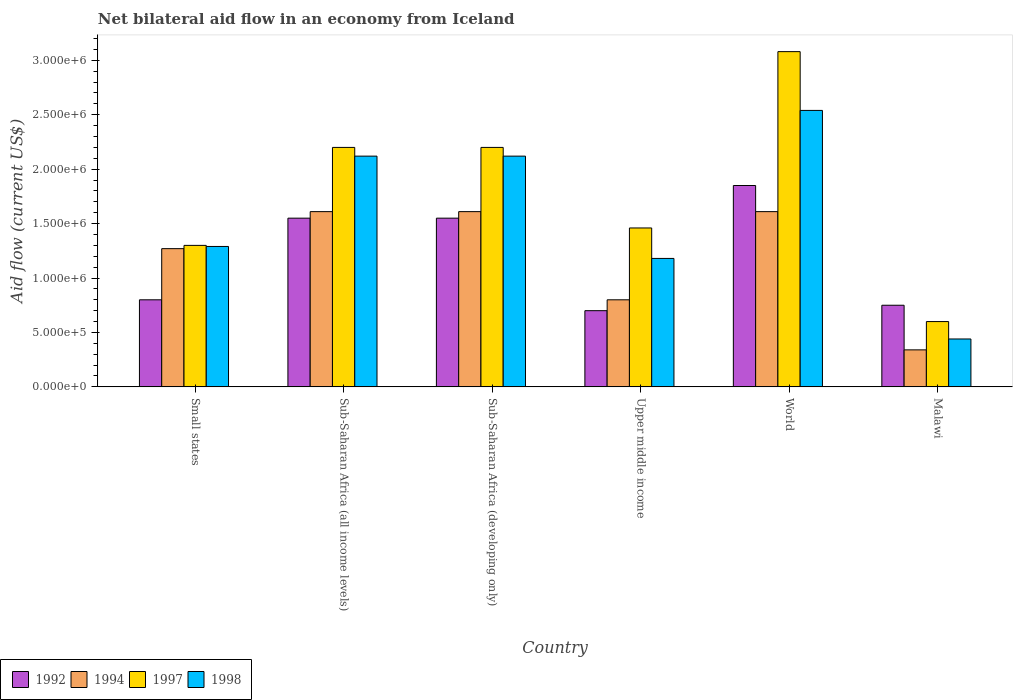Are the number of bars per tick equal to the number of legend labels?
Ensure brevity in your answer.  Yes. Are the number of bars on each tick of the X-axis equal?
Make the answer very short. Yes. What is the label of the 3rd group of bars from the left?
Your answer should be very brief. Sub-Saharan Africa (developing only). What is the net bilateral aid flow in 1994 in Sub-Saharan Africa (all income levels)?
Ensure brevity in your answer.  1.61e+06. Across all countries, what is the maximum net bilateral aid flow in 1998?
Provide a short and direct response. 2.54e+06. In which country was the net bilateral aid flow in 1994 maximum?
Your answer should be very brief. Sub-Saharan Africa (all income levels). In which country was the net bilateral aid flow in 1998 minimum?
Make the answer very short. Malawi. What is the total net bilateral aid flow in 1997 in the graph?
Provide a succinct answer. 1.08e+07. What is the difference between the net bilateral aid flow in 1994 in Sub-Saharan Africa (all income levels) and that in Upper middle income?
Provide a succinct answer. 8.10e+05. What is the difference between the net bilateral aid flow in 1998 in World and the net bilateral aid flow in 1997 in Small states?
Offer a very short reply. 1.24e+06. What is the average net bilateral aid flow in 1998 per country?
Provide a succinct answer. 1.62e+06. What is the ratio of the net bilateral aid flow in 1998 in Small states to that in World?
Make the answer very short. 0.51. Is the net bilateral aid flow in 1998 in Malawi less than that in Sub-Saharan Africa (all income levels)?
Offer a terse response. Yes. Is the difference between the net bilateral aid flow in 1998 in Small states and Sub-Saharan Africa (all income levels) greater than the difference between the net bilateral aid flow in 1992 in Small states and Sub-Saharan Africa (all income levels)?
Offer a terse response. No. What is the difference between the highest and the lowest net bilateral aid flow in 1994?
Provide a short and direct response. 1.27e+06. In how many countries, is the net bilateral aid flow in 1998 greater than the average net bilateral aid flow in 1998 taken over all countries?
Make the answer very short. 3. Is the sum of the net bilateral aid flow in 1992 in Malawi and Upper middle income greater than the maximum net bilateral aid flow in 1997 across all countries?
Your answer should be very brief. No. Is it the case that in every country, the sum of the net bilateral aid flow in 1997 and net bilateral aid flow in 1992 is greater than the sum of net bilateral aid flow in 1994 and net bilateral aid flow in 1998?
Your answer should be compact. No. What does the 1st bar from the left in Small states represents?
Give a very brief answer. 1992. What is the difference between two consecutive major ticks on the Y-axis?
Give a very brief answer. 5.00e+05. Are the values on the major ticks of Y-axis written in scientific E-notation?
Give a very brief answer. Yes. Does the graph contain grids?
Give a very brief answer. No. Where does the legend appear in the graph?
Your response must be concise. Bottom left. How are the legend labels stacked?
Your answer should be very brief. Horizontal. What is the title of the graph?
Give a very brief answer. Net bilateral aid flow in an economy from Iceland. Does "1999" appear as one of the legend labels in the graph?
Your answer should be compact. No. What is the Aid flow (current US$) in 1994 in Small states?
Your answer should be very brief. 1.27e+06. What is the Aid flow (current US$) in 1997 in Small states?
Provide a succinct answer. 1.30e+06. What is the Aid flow (current US$) in 1998 in Small states?
Offer a terse response. 1.29e+06. What is the Aid flow (current US$) of 1992 in Sub-Saharan Africa (all income levels)?
Offer a very short reply. 1.55e+06. What is the Aid flow (current US$) in 1994 in Sub-Saharan Africa (all income levels)?
Give a very brief answer. 1.61e+06. What is the Aid flow (current US$) of 1997 in Sub-Saharan Africa (all income levels)?
Your answer should be compact. 2.20e+06. What is the Aid flow (current US$) in 1998 in Sub-Saharan Africa (all income levels)?
Offer a terse response. 2.12e+06. What is the Aid flow (current US$) of 1992 in Sub-Saharan Africa (developing only)?
Provide a succinct answer. 1.55e+06. What is the Aid flow (current US$) of 1994 in Sub-Saharan Africa (developing only)?
Ensure brevity in your answer.  1.61e+06. What is the Aid flow (current US$) of 1997 in Sub-Saharan Africa (developing only)?
Provide a succinct answer. 2.20e+06. What is the Aid flow (current US$) of 1998 in Sub-Saharan Africa (developing only)?
Keep it short and to the point. 2.12e+06. What is the Aid flow (current US$) of 1994 in Upper middle income?
Offer a very short reply. 8.00e+05. What is the Aid flow (current US$) of 1997 in Upper middle income?
Provide a short and direct response. 1.46e+06. What is the Aid flow (current US$) in 1998 in Upper middle income?
Provide a short and direct response. 1.18e+06. What is the Aid flow (current US$) in 1992 in World?
Ensure brevity in your answer.  1.85e+06. What is the Aid flow (current US$) of 1994 in World?
Offer a very short reply. 1.61e+06. What is the Aid flow (current US$) of 1997 in World?
Your response must be concise. 3.08e+06. What is the Aid flow (current US$) of 1998 in World?
Your response must be concise. 2.54e+06. What is the Aid flow (current US$) in 1992 in Malawi?
Provide a short and direct response. 7.50e+05. What is the Aid flow (current US$) in 1998 in Malawi?
Your answer should be very brief. 4.40e+05. Across all countries, what is the maximum Aid flow (current US$) of 1992?
Offer a very short reply. 1.85e+06. Across all countries, what is the maximum Aid flow (current US$) of 1994?
Your answer should be compact. 1.61e+06. Across all countries, what is the maximum Aid flow (current US$) in 1997?
Keep it short and to the point. 3.08e+06. Across all countries, what is the maximum Aid flow (current US$) in 1998?
Offer a very short reply. 2.54e+06. Across all countries, what is the minimum Aid flow (current US$) of 1992?
Give a very brief answer. 7.00e+05. Across all countries, what is the minimum Aid flow (current US$) in 1997?
Offer a terse response. 6.00e+05. Across all countries, what is the minimum Aid flow (current US$) of 1998?
Keep it short and to the point. 4.40e+05. What is the total Aid flow (current US$) of 1992 in the graph?
Offer a terse response. 7.20e+06. What is the total Aid flow (current US$) of 1994 in the graph?
Keep it short and to the point. 7.24e+06. What is the total Aid flow (current US$) in 1997 in the graph?
Offer a terse response. 1.08e+07. What is the total Aid flow (current US$) of 1998 in the graph?
Your answer should be very brief. 9.69e+06. What is the difference between the Aid flow (current US$) in 1992 in Small states and that in Sub-Saharan Africa (all income levels)?
Keep it short and to the point. -7.50e+05. What is the difference between the Aid flow (current US$) in 1997 in Small states and that in Sub-Saharan Africa (all income levels)?
Keep it short and to the point. -9.00e+05. What is the difference between the Aid flow (current US$) in 1998 in Small states and that in Sub-Saharan Africa (all income levels)?
Provide a succinct answer. -8.30e+05. What is the difference between the Aid flow (current US$) in 1992 in Small states and that in Sub-Saharan Africa (developing only)?
Your answer should be very brief. -7.50e+05. What is the difference between the Aid flow (current US$) in 1994 in Small states and that in Sub-Saharan Africa (developing only)?
Offer a terse response. -3.40e+05. What is the difference between the Aid flow (current US$) of 1997 in Small states and that in Sub-Saharan Africa (developing only)?
Your response must be concise. -9.00e+05. What is the difference between the Aid flow (current US$) in 1998 in Small states and that in Sub-Saharan Africa (developing only)?
Offer a terse response. -8.30e+05. What is the difference between the Aid flow (current US$) of 1992 in Small states and that in Upper middle income?
Provide a short and direct response. 1.00e+05. What is the difference between the Aid flow (current US$) of 1994 in Small states and that in Upper middle income?
Your response must be concise. 4.70e+05. What is the difference between the Aid flow (current US$) of 1998 in Small states and that in Upper middle income?
Keep it short and to the point. 1.10e+05. What is the difference between the Aid flow (current US$) of 1992 in Small states and that in World?
Make the answer very short. -1.05e+06. What is the difference between the Aid flow (current US$) in 1994 in Small states and that in World?
Your answer should be compact. -3.40e+05. What is the difference between the Aid flow (current US$) in 1997 in Small states and that in World?
Provide a succinct answer. -1.78e+06. What is the difference between the Aid flow (current US$) of 1998 in Small states and that in World?
Ensure brevity in your answer.  -1.25e+06. What is the difference between the Aid flow (current US$) in 1992 in Small states and that in Malawi?
Provide a short and direct response. 5.00e+04. What is the difference between the Aid flow (current US$) in 1994 in Small states and that in Malawi?
Ensure brevity in your answer.  9.30e+05. What is the difference between the Aid flow (current US$) in 1997 in Small states and that in Malawi?
Keep it short and to the point. 7.00e+05. What is the difference between the Aid flow (current US$) in 1998 in Small states and that in Malawi?
Offer a terse response. 8.50e+05. What is the difference between the Aid flow (current US$) in 1994 in Sub-Saharan Africa (all income levels) and that in Sub-Saharan Africa (developing only)?
Make the answer very short. 0. What is the difference between the Aid flow (current US$) in 1997 in Sub-Saharan Africa (all income levels) and that in Sub-Saharan Africa (developing only)?
Your answer should be compact. 0. What is the difference between the Aid flow (current US$) of 1998 in Sub-Saharan Africa (all income levels) and that in Sub-Saharan Africa (developing only)?
Offer a terse response. 0. What is the difference between the Aid flow (current US$) in 1992 in Sub-Saharan Africa (all income levels) and that in Upper middle income?
Provide a succinct answer. 8.50e+05. What is the difference between the Aid flow (current US$) in 1994 in Sub-Saharan Africa (all income levels) and that in Upper middle income?
Your response must be concise. 8.10e+05. What is the difference between the Aid flow (current US$) of 1997 in Sub-Saharan Africa (all income levels) and that in Upper middle income?
Your response must be concise. 7.40e+05. What is the difference between the Aid flow (current US$) in 1998 in Sub-Saharan Africa (all income levels) and that in Upper middle income?
Provide a succinct answer. 9.40e+05. What is the difference between the Aid flow (current US$) in 1992 in Sub-Saharan Africa (all income levels) and that in World?
Your response must be concise. -3.00e+05. What is the difference between the Aid flow (current US$) of 1997 in Sub-Saharan Africa (all income levels) and that in World?
Offer a terse response. -8.80e+05. What is the difference between the Aid flow (current US$) of 1998 in Sub-Saharan Africa (all income levels) and that in World?
Keep it short and to the point. -4.20e+05. What is the difference between the Aid flow (current US$) in 1994 in Sub-Saharan Africa (all income levels) and that in Malawi?
Offer a terse response. 1.27e+06. What is the difference between the Aid flow (current US$) of 1997 in Sub-Saharan Africa (all income levels) and that in Malawi?
Offer a very short reply. 1.60e+06. What is the difference between the Aid flow (current US$) in 1998 in Sub-Saharan Africa (all income levels) and that in Malawi?
Offer a very short reply. 1.68e+06. What is the difference between the Aid flow (current US$) in 1992 in Sub-Saharan Africa (developing only) and that in Upper middle income?
Ensure brevity in your answer.  8.50e+05. What is the difference between the Aid flow (current US$) of 1994 in Sub-Saharan Africa (developing only) and that in Upper middle income?
Ensure brevity in your answer.  8.10e+05. What is the difference between the Aid flow (current US$) of 1997 in Sub-Saharan Africa (developing only) and that in Upper middle income?
Offer a very short reply. 7.40e+05. What is the difference between the Aid flow (current US$) of 1998 in Sub-Saharan Africa (developing only) and that in Upper middle income?
Give a very brief answer. 9.40e+05. What is the difference between the Aid flow (current US$) in 1992 in Sub-Saharan Africa (developing only) and that in World?
Give a very brief answer. -3.00e+05. What is the difference between the Aid flow (current US$) of 1997 in Sub-Saharan Africa (developing only) and that in World?
Your answer should be very brief. -8.80e+05. What is the difference between the Aid flow (current US$) of 1998 in Sub-Saharan Africa (developing only) and that in World?
Make the answer very short. -4.20e+05. What is the difference between the Aid flow (current US$) in 1992 in Sub-Saharan Africa (developing only) and that in Malawi?
Your answer should be compact. 8.00e+05. What is the difference between the Aid flow (current US$) of 1994 in Sub-Saharan Africa (developing only) and that in Malawi?
Your response must be concise. 1.27e+06. What is the difference between the Aid flow (current US$) of 1997 in Sub-Saharan Africa (developing only) and that in Malawi?
Keep it short and to the point. 1.60e+06. What is the difference between the Aid flow (current US$) of 1998 in Sub-Saharan Africa (developing only) and that in Malawi?
Your answer should be compact. 1.68e+06. What is the difference between the Aid flow (current US$) in 1992 in Upper middle income and that in World?
Your response must be concise. -1.15e+06. What is the difference between the Aid flow (current US$) of 1994 in Upper middle income and that in World?
Your response must be concise. -8.10e+05. What is the difference between the Aid flow (current US$) in 1997 in Upper middle income and that in World?
Give a very brief answer. -1.62e+06. What is the difference between the Aid flow (current US$) in 1998 in Upper middle income and that in World?
Provide a succinct answer. -1.36e+06. What is the difference between the Aid flow (current US$) of 1997 in Upper middle income and that in Malawi?
Provide a short and direct response. 8.60e+05. What is the difference between the Aid flow (current US$) of 1998 in Upper middle income and that in Malawi?
Offer a very short reply. 7.40e+05. What is the difference between the Aid flow (current US$) in 1992 in World and that in Malawi?
Your answer should be very brief. 1.10e+06. What is the difference between the Aid flow (current US$) in 1994 in World and that in Malawi?
Ensure brevity in your answer.  1.27e+06. What is the difference between the Aid flow (current US$) of 1997 in World and that in Malawi?
Offer a very short reply. 2.48e+06. What is the difference between the Aid flow (current US$) in 1998 in World and that in Malawi?
Provide a succinct answer. 2.10e+06. What is the difference between the Aid flow (current US$) of 1992 in Small states and the Aid flow (current US$) of 1994 in Sub-Saharan Africa (all income levels)?
Give a very brief answer. -8.10e+05. What is the difference between the Aid flow (current US$) of 1992 in Small states and the Aid flow (current US$) of 1997 in Sub-Saharan Africa (all income levels)?
Your answer should be compact. -1.40e+06. What is the difference between the Aid flow (current US$) in 1992 in Small states and the Aid flow (current US$) in 1998 in Sub-Saharan Africa (all income levels)?
Provide a short and direct response. -1.32e+06. What is the difference between the Aid flow (current US$) in 1994 in Small states and the Aid flow (current US$) in 1997 in Sub-Saharan Africa (all income levels)?
Keep it short and to the point. -9.30e+05. What is the difference between the Aid flow (current US$) in 1994 in Small states and the Aid flow (current US$) in 1998 in Sub-Saharan Africa (all income levels)?
Give a very brief answer. -8.50e+05. What is the difference between the Aid flow (current US$) of 1997 in Small states and the Aid flow (current US$) of 1998 in Sub-Saharan Africa (all income levels)?
Give a very brief answer. -8.20e+05. What is the difference between the Aid flow (current US$) of 1992 in Small states and the Aid flow (current US$) of 1994 in Sub-Saharan Africa (developing only)?
Ensure brevity in your answer.  -8.10e+05. What is the difference between the Aid flow (current US$) in 1992 in Small states and the Aid flow (current US$) in 1997 in Sub-Saharan Africa (developing only)?
Make the answer very short. -1.40e+06. What is the difference between the Aid flow (current US$) of 1992 in Small states and the Aid flow (current US$) of 1998 in Sub-Saharan Africa (developing only)?
Ensure brevity in your answer.  -1.32e+06. What is the difference between the Aid flow (current US$) of 1994 in Small states and the Aid flow (current US$) of 1997 in Sub-Saharan Africa (developing only)?
Your answer should be compact. -9.30e+05. What is the difference between the Aid flow (current US$) of 1994 in Small states and the Aid flow (current US$) of 1998 in Sub-Saharan Africa (developing only)?
Make the answer very short. -8.50e+05. What is the difference between the Aid flow (current US$) in 1997 in Small states and the Aid flow (current US$) in 1998 in Sub-Saharan Africa (developing only)?
Give a very brief answer. -8.20e+05. What is the difference between the Aid flow (current US$) of 1992 in Small states and the Aid flow (current US$) of 1994 in Upper middle income?
Your response must be concise. 0. What is the difference between the Aid flow (current US$) in 1992 in Small states and the Aid flow (current US$) in 1997 in Upper middle income?
Offer a terse response. -6.60e+05. What is the difference between the Aid flow (current US$) in 1992 in Small states and the Aid flow (current US$) in 1998 in Upper middle income?
Make the answer very short. -3.80e+05. What is the difference between the Aid flow (current US$) of 1994 in Small states and the Aid flow (current US$) of 1997 in Upper middle income?
Give a very brief answer. -1.90e+05. What is the difference between the Aid flow (current US$) of 1992 in Small states and the Aid flow (current US$) of 1994 in World?
Your response must be concise. -8.10e+05. What is the difference between the Aid flow (current US$) of 1992 in Small states and the Aid flow (current US$) of 1997 in World?
Your answer should be compact. -2.28e+06. What is the difference between the Aid flow (current US$) in 1992 in Small states and the Aid flow (current US$) in 1998 in World?
Provide a succinct answer. -1.74e+06. What is the difference between the Aid flow (current US$) in 1994 in Small states and the Aid flow (current US$) in 1997 in World?
Your response must be concise. -1.81e+06. What is the difference between the Aid flow (current US$) of 1994 in Small states and the Aid flow (current US$) of 1998 in World?
Your response must be concise. -1.27e+06. What is the difference between the Aid flow (current US$) in 1997 in Small states and the Aid flow (current US$) in 1998 in World?
Provide a succinct answer. -1.24e+06. What is the difference between the Aid flow (current US$) in 1992 in Small states and the Aid flow (current US$) in 1994 in Malawi?
Your answer should be compact. 4.60e+05. What is the difference between the Aid flow (current US$) in 1992 in Small states and the Aid flow (current US$) in 1997 in Malawi?
Your answer should be very brief. 2.00e+05. What is the difference between the Aid flow (current US$) of 1994 in Small states and the Aid flow (current US$) of 1997 in Malawi?
Offer a terse response. 6.70e+05. What is the difference between the Aid flow (current US$) in 1994 in Small states and the Aid flow (current US$) in 1998 in Malawi?
Make the answer very short. 8.30e+05. What is the difference between the Aid flow (current US$) in 1997 in Small states and the Aid flow (current US$) in 1998 in Malawi?
Offer a very short reply. 8.60e+05. What is the difference between the Aid flow (current US$) in 1992 in Sub-Saharan Africa (all income levels) and the Aid flow (current US$) in 1994 in Sub-Saharan Africa (developing only)?
Ensure brevity in your answer.  -6.00e+04. What is the difference between the Aid flow (current US$) of 1992 in Sub-Saharan Africa (all income levels) and the Aid flow (current US$) of 1997 in Sub-Saharan Africa (developing only)?
Keep it short and to the point. -6.50e+05. What is the difference between the Aid flow (current US$) of 1992 in Sub-Saharan Africa (all income levels) and the Aid flow (current US$) of 1998 in Sub-Saharan Africa (developing only)?
Offer a terse response. -5.70e+05. What is the difference between the Aid flow (current US$) in 1994 in Sub-Saharan Africa (all income levels) and the Aid flow (current US$) in 1997 in Sub-Saharan Africa (developing only)?
Make the answer very short. -5.90e+05. What is the difference between the Aid flow (current US$) in 1994 in Sub-Saharan Africa (all income levels) and the Aid flow (current US$) in 1998 in Sub-Saharan Africa (developing only)?
Provide a succinct answer. -5.10e+05. What is the difference between the Aid flow (current US$) in 1992 in Sub-Saharan Africa (all income levels) and the Aid flow (current US$) in 1994 in Upper middle income?
Offer a terse response. 7.50e+05. What is the difference between the Aid flow (current US$) in 1994 in Sub-Saharan Africa (all income levels) and the Aid flow (current US$) in 1998 in Upper middle income?
Your answer should be compact. 4.30e+05. What is the difference between the Aid flow (current US$) in 1997 in Sub-Saharan Africa (all income levels) and the Aid flow (current US$) in 1998 in Upper middle income?
Ensure brevity in your answer.  1.02e+06. What is the difference between the Aid flow (current US$) in 1992 in Sub-Saharan Africa (all income levels) and the Aid flow (current US$) in 1994 in World?
Provide a succinct answer. -6.00e+04. What is the difference between the Aid flow (current US$) in 1992 in Sub-Saharan Africa (all income levels) and the Aid flow (current US$) in 1997 in World?
Make the answer very short. -1.53e+06. What is the difference between the Aid flow (current US$) in 1992 in Sub-Saharan Africa (all income levels) and the Aid flow (current US$) in 1998 in World?
Provide a short and direct response. -9.90e+05. What is the difference between the Aid flow (current US$) of 1994 in Sub-Saharan Africa (all income levels) and the Aid flow (current US$) of 1997 in World?
Make the answer very short. -1.47e+06. What is the difference between the Aid flow (current US$) of 1994 in Sub-Saharan Africa (all income levels) and the Aid flow (current US$) of 1998 in World?
Your response must be concise. -9.30e+05. What is the difference between the Aid flow (current US$) of 1997 in Sub-Saharan Africa (all income levels) and the Aid flow (current US$) of 1998 in World?
Your response must be concise. -3.40e+05. What is the difference between the Aid flow (current US$) in 1992 in Sub-Saharan Africa (all income levels) and the Aid flow (current US$) in 1994 in Malawi?
Your answer should be very brief. 1.21e+06. What is the difference between the Aid flow (current US$) in 1992 in Sub-Saharan Africa (all income levels) and the Aid flow (current US$) in 1997 in Malawi?
Offer a very short reply. 9.50e+05. What is the difference between the Aid flow (current US$) in 1992 in Sub-Saharan Africa (all income levels) and the Aid flow (current US$) in 1998 in Malawi?
Offer a very short reply. 1.11e+06. What is the difference between the Aid flow (current US$) in 1994 in Sub-Saharan Africa (all income levels) and the Aid flow (current US$) in 1997 in Malawi?
Keep it short and to the point. 1.01e+06. What is the difference between the Aid flow (current US$) in 1994 in Sub-Saharan Africa (all income levels) and the Aid flow (current US$) in 1998 in Malawi?
Ensure brevity in your answer.  1.17e+06. What is the difference between the Aid flow (current US$) of 1997 in Sub-Saharan Africa (all income levels) and the Aid flow (current US$) of 1998 in Malawi?
Give a very brief answer. 1.76e+06. What is the difference between the Aid flow (current US$) of 1992 in Sub-Saharan Africa (developing only) and the Aid flow (current US$) of 1994 in Upper middle income?
Offer a terse response. 7.50e+05. What is the difference between the Aid flow (current US$) of 1994 in Sub-Saharan Africa (developing only) and the Aid flow (current US$) of 1997 in Upper middle income?
Give a very brief answer. 1.50e+05. What is the difference between the Aid flow (current US$) of 1997 in Sub-Saharan Africa (developing only) and the Aid flow (current US$) of 1998 in Upper middle income?
Your answer should be compact. 1.02e+06. What is the difference between the Aid flow (current US$) in 1992 in Sub-Saharan Africa (developing only) and the Aid flow (current US$) in 1997 in World?
Make the answer very short. -1.53e+06. What is the difference between the Aid flow (current US$) of 1992 in Sub-Saharan Africa (developing only) and the Aid flow (current US$) of 1998 in World?
Make the answer very short. -9.90e+05. What is the difference between the Aid flow (current US$) in 1994 in Sub-Saharan Africa (developing only) and the Aid flow (current US$) in 1997 in World?
Make the answer very short. -1.47e+06. What is the difference between the Aid flow (current US$) of 1994 in Sub-Saharan Africa (developing only) and the Aid flow (current US$) of 1998 in World?
Offer a very short reply. -9.30e+05. What is the difference between the Aid flow (current US$) in 1992 in Sub-Saharan Africa (developing only) and the Aid flow (current US$) in 1994 in Malawi?
Provide a short and direct response. 1.21e+06. What is the difference between the Aid flow (current US$) in 1992 in Sub-Saharan Africa (developing only) and the Aid flow (current US$) in 1997 in Malawi?
Provide a succinct answer. 9.50e+05. What is the difference between the Aid flow (current US$) in 1992 in Sub-Saharan Africa (developing only) and the Aid flow (current US$) in 1998 in Malawi?
Offer a very short reply. 1.11e+06. What is the difference between the Aid flow (current US$) in 1994 in Sub-Saharan Africa (developing only) and the Aid flow (current US$) in 1997 in Malawi?
Keep it short and to the point. 1.01e+06. What is the difference between the Aid flow (current US$) of 1994 in Sub-Saharan Africa (developing only) and the Aid flow (current US$) of 1998 in Malawi?
Offer a terse response. 1.17e+06. What is the difference between the Aid flow (current US$) in 1997 in Sub-Saharan Africa (developing only) and the Aid flow (current US$) in 1998 in Malawi?
Offer a very short reply. 1.76e+06. What is the difference between the Aid flow (current US$) in 1992 in Upper middle income and the Aid flow (current US$) in 1994 in World?
Keep it short and to the point. -9.10e+05. What is the difference between the Aid flow (current US$) of 1992 in Upper middle income and the Aid flow (current US$) of 1997 in World?
Your answer should be very brief. -2.38e+06. What is the difference between the Aid flow (current US$) of 1992 in Upper middle income and the Aid flow (current US$) of 1998 in World?
Your answer should be very brief. -1.84e+06. What is the difference between the Aid flow (current US$) in 1994 in Upper middle income and the Aid flow (current US$) in 1997 in World?
Make the answer very short. -2.28e+06. What is the difference between the Aid flow (current US$) in 1994 in Upper middle income and the Aid flow (current US$) in 1998 in World?
Make the answer very short. -1.74e+06. What is the difference between the Aid flow (current US$) of 1997 in Upper middle income and the Aid flow (current US$) of 1998 in World?
Ensure brevity in your answer.  -1.08e+06. What is the difference between the Aid flow (current US$) of 1992 in Upper middle income and the Aid flow (current US$) of 1997 in Malawi?
Make the answer very short. 1.00e+05. What is the difference between the Aid flow (current US$) in 1994 in Upper middle income and the Aid flow (current US$) in 1998 in Malawi?
Make the answer very short. 3.60e+05. What is the difference between the Aid flow (current US$) in 1997 in Upper middle income and the Aid flow (current US$) in 1998 in Malawi?
Your response must be concise. 1.02e+06. What is the difference between the Aid flow (current US$) of 1992 in World and the Aid flow (current US$) of 1994 in Malawi?
Offer a very short reply. 1.51e+06. What is the difference between the Aid flow (current US$) in 1992 in World and the Aid flow (current US$) in 1997 in Malawi?
Your answer should be compact. 1.25e+06. What is the difference between the Aid flow (current US$) of 1992 in World and the Aid flow (current US$) of 1998 in Malawi?
Offer a very short reply. 1.41e+06. What is the difference between the Aid flow (current US$) of 1994 in World and the Aid flow (current US$) of 1997 in Malawi?
Your response must be concise. 1.01e+06. What is the difference between the Aid flow (current US$) of 1994 in World and the Aid flow (current US$) of 1998 in Malawi?
Give a very brief answer. 1.17e+06. What is the difference between the Aid flow (current US$) in 1997 in World and the Aid flow (current US$) in 1998 in Malawi?
Offer a terse response. 2.64e+06. What is the average Aid flow (current US$) in 1992 per country?
Provide a succinct answer. 1.20e+06. What is the average Aid flow (current US$) of 1994 per country?
Provide a short and direct response. 1.21e+06. What is the average Aid flow (current US$) in 1997 per country?
Provide a short and direct response. 1.81e+06. What is the average Aid flow (current US$) of 1998 per country?
Your answer should be very brief. 1.62e+06. What is the difference between the Aid flow (current US$) in 1992 and Aid flow (current US$) in 1994 in Small states?
Your response must be concise. -4.70e+05. What is the difference between the Aid flow (current US$) in 1992 and Aid flow (current US$) in 1997 in Small states?
Your response must be concise. -5.00e+05. What is the difference between the Aid flow (current US$) of 1992 and Aid flow (current US$) of 1998 in Small states?
Your response must be concise. -4.90e+05. What is the difference between the Aid flow (current US$) in 1994 and Aid flow (current US$) in 1997 in Small states?
Ensure brevity in your answer.  -3.00e+04. What is the difference between the Aid flow (current US$) in 1992 and Aid flow (current US$) in 1997 in Sub-Saharan Africa (all income levels)?
Keep it short and to the point. -6.50e+05. What is the difference between the Aid flow (current US$) of 1992 and Aid flow (current US$) of 1998 in Sub-Saharan Africa (all income levels)?
Make the answer very short. -5.70e+05. What is the difference between the Aid flow (current US$) of 1994 and Aid flow (current US$) of 1997 in Sub-Saharan Africa (all income levels)?
Offer a very short reply. -5.90e+05. What is the difference between the Aid flow (current US$) of 1994 and Aid flow (current US$) of 1998 in Sub-Saharan Africa (all income levels)?
Offer a very short reply. -5.10e+05. What is the difference between the Aid flow (current US$) in 1997 and Aid flow (current US$) in 1998 in Sub-Saharan Africa (all income levels)?
Ensure brevity in your answer.  8.00e+04. What is the difference between the Aid flow (current US$) of 1992 and Aid flow (current US$) of 1997 in Sub-Saharan Africa (developing only)?
Provide a succinct answer. -6.50e+05. What is the difference between the Aid flow (current US$) in 1992 and Aid flow (current US$) in 1998 in Sub-Saharan Africa (developing only)?
Make the answer very short. -5.70e+05. What is the difference between the Aid flow (current US$) of 1994 and Aid flow (current US$) of 1997 in Sub-Saharan Africa (developing only)?
Your response must be concise. -5.90e+05. What is the difference between the Aid flow (current US$) in 1994 and Aid flow (current US$) in 1998 in Sub-Saharan Africa (developing only)?
Ensure brevity in your answer.  -5.10e+05. What is the difference between the Aid flow (current US$) in 1992 and Aid flow (current US$) in 1994 in Upper middle income?
Offer a very short reply. -1.00e+05. What is the difference between the Aid flow (current US$) of 1992 and Aid flow (current US$) of 1997 in Upper middle income?
Your answer should be compact. -7.60e+05. What is the difference between the Aid flow (current US$) in 1992 and Aid flow (current US$) in 1998 in Upper middle income?
Your response must be concise. -4.80e+05. What is the difference between the Aid flow (current US$) of 1994 and Aid flow (current US$) of 1997 in Upper middle income?
Provide a succinct answer. -6.60e+05. What is the difference between the Aid flow (current US$) of 1994 and Aid flow (current US$) of 1998 in Upper middle income?
Provide a short and direct response. -3.80e+05. What is the difference between the Aid flow (current US$) of 1997 and Aid flow (current US$) of 1998 in Upper middle income?
Your answer should be compact. 2.80e+05. What is the difference between the Aid flow (current US$) in 1992 and Aid flow (current US$) in 1994 in World?
Keep it short and to the point. 2.40e+05. What is the difference between the Aid flow (current US$) of 1992 and Aid flow (current US$) of 1997 in World?
Provide a succinct answer. -1.23e+06. What is the difference between the Aid flow (current US$) in 1992 and Aid flow (current US$) in 1998 in World?
Give a very brief answer. -6.90e+05. What is the difference between the Aid flow (current US$) of 1994 and Aid flow (current US$) of 1997 in World?
Make the answer very short. -1.47e+06. What is the difference between the Aid flow (current US$) of 1994 and Aid flow (current US$) of 1998 in World?
Provide a succinct answer. -9.30e+05. What is the difference between the Aid flow (current US$) in 1997 and Aid flow (current US$) in 1998 in World?
Provide a short and direct response. 5.40e+05. What is the difference between the Aid flow (current US$) in 1992 and Aid flow (current US$) in 1998 in Malawi?
Your response must be concise. 3.10e+05. What is the difference between the Aid flow (current US$) of 1994 and Aid flow (current US$) of 1997 in Malawi?
Provide a succinct answer. -2.60e+05. What is the difference between the Aid flow (current US$) of 1997 and Aid flow (current US$) of 1998 in Malawi?
Your response must be concise. 1.60e+05. What is the ratio of the Aid flow (current US$) of 1992 in Small states to that in Sub-Saharan Africa (all income levels)?
Offer a very short reply. 0.52. What is the ratio of the Aid flow (current US$) of 1994 in Small states to that in Sub-Saharan Africa (all income levels)?
Offer a terse response. 0.79. What is the ratio of the Aid flow (current US$) of 1997 in Small states to that in Sub-Saharan Africa (all income levels)?
Make the answer very short. 0.59. What is the ratio of the Aid flow (current US$) in 1998 in Small states to that in Sub-Saharan Africa (all income levels)?
Keep it short and to the point. 0.61. What is the ratio of the Aid flow (current US$) in 1992 in Small states to that in Sub-Saharan Africa (developing only)?
Offer a terse response. 0.52. What is the ratio of the Aid flow (current US$) of 1994 in Small states to that in Sub-Saharan Africa (developing only)?
Ensure brevity in your answer.  0.79. What is the ratio of the Aid flow (current US$) of 1997 in Small states to that in Sub-Saharan Africa (developing only)?
Your response must be concise. 0.59. What is the ratio of the Aid flow (current US$) in 1998 in Small states to that in Sub-Saharan Africa (developing only)?
Your answer should be compact. 0.61. What is the ratio of the Aid flow (current US$) in 1994 in Small states to that in Upper middle income?
Your response must be concise. 1.59. What is the ratio of the Aid flow (current US$) in 1997 in Small states to that in Upper middle income?
Your response must be concise. 0.89. What is the ratio of the Aid flow (current US$) in 1998 in Small states to that in Upper middle income?
Give a very brief answer. 1.09. What is the ratio of the Aid flow (current US$) of 1992 in Small states to that in World?
Provide a succinct answer. 0.43. What is the ratio of the Aid flow (current US$) in 1994 in Small states to that in World?
Your answer should be very brief. 0.79. What is the ratio of the Aid flow (current US$) in 1997 in Small states to that in World?
Your answer should be compact. 0.42. What is the ratio of the Aid flow (current US$) in 1998 in Small states to that in World?
Your answer should be compact. 0.51. What is the ratio of the Aid flow (current US$) of 1992 in Small states to that in Malawi?
Your answer should be compact. 1.07. What is the ratio of the Aid flow (current US$) of 1994 in Small states to that in Malawi?
Give a very brief answer. 3.74. What is the ratio of the Aid flow (current US$) in 1997 in Small states to that in Malawi?
Ensure brevity in your answer.  2.17. What is the ratio of the Aid flow (current US$) of 1998 in Small states to that in Malawi?
Offer a very short reply. 2.93. What is the ratio of the Aid flow (current US$) in 1994 in Sub-Saharan Africa (all income levels) to that in Sub-Saharan Africa (developing only)?
Your answer should be compact. 1. What is the ratio of the Aid flow (current US$) in 1997 in Sub-Saharan Africa (all income levels) to that in Sub-Saharan Africa (developing only)?
Offer a terse response. 1. What is the ratio of the Aid flow (current US$) in 1998 in Sub-Saharan Africa (all income levels) to that in Sub-Saharan Africa (developing only)?
Your answer should be compact. 1. What is the ratio of the Aid flow (current US$) in 1992 in Sub-Saharan Africa (all income levels) to that in Upper middle income?
Provide a succinct answer. 2.21. What is the ratio of the Aid flow (current US$) in 1994 in Sub-Saharan Africa (all income levels) to that in Upper middle income?
Offer a terse response. 2.01. What is the ratio of the Aid flow (current US$) of 1997 in Sub-Saharan Africa (all income levels) to that in Upper middle income?
Make the answer very short. 1.51. What is the ratio of the Aid flow (current US$) in 1998 in Sub-Saharan Africa (all income levels) to that in Upper middle income?
Offer a very short reply. 1.8. What is the ratio of the Aid flow (current US$) in 1992 in Sub-Saharan Africa (all income levels) to that in World?
Offer a terse response. 0.84. What is the ratio of the Aid flow (current US$) in 1994 in Sub-Saharan Africa (all income levels) to that in World?
Make the answer very short. 1. What is the ratio of the Aid flow (current US$) of 1998 in Sub-Saharan Africa (all income levels) to that in World?
Provide a short and direct response. 0.83. What is the ratio of the Aid flow (current US$) in 1992 in Sub-Saharan Africa (all income levels) to that in Malawi?
Offer a very short reply. 2.07. What is the ratio of the Aid flow (current US$) of 1994 in Sub-Saharan Africa (all income levels) to that in Malawi?
Keep it short and to the point. 4.74. What is the ratio of the Aid flow (current US$) in 1997 in Sub-Saharan Africa (all income levels) to that in Malawi?
Provide a short and direct response. 3.67. What is the ratio of the Aid flow (current US$) in 1998 in Sub-Saharan Africa (all income levels) to that in Malawi?
Ensure brevity in your answer.  4.82. What is the ratio of the Aid flow (current US$) in 1992 in Sub-Saharan Africa (developing only) to that in Upper middle income?
Keep it short and to the point. 2.21. What is the ratio of the Aid flow (current US$) of 1994 in Sub-Saharan Africa (developing only) to that in Upper middle income?
Offer a very short reply. 2.01. What is the ratio of the Aid flow (current US$) in 1997 in Sub-Saharan Africa (developing only) to that in Upper middle income?
Your answer should be compact. 1.51. What is the ratio of the Aid flow (current US$) of 1998 in Sub-Saharan Africa (developing only) to that in Upper middle income?
Ensure brevity in your answer.  1.8. What is the ratio of the Aid flow (current US$) in 1992 in Sub-Saharan Africa (developing only) to that in World?
Offer a terse response. 0.84. What is the ratio of the Aid flow (current US$) of 1997 in Sub-Saharan Africa (developing only) to that in World?
Keep it short and to the point. 0.71. What is the ratio of the Aid flow (current US$) of 1998 in Sub-Saharan Africa (developing only) to that in World?
Provide a succinct answer. 0.83. What is the ratio of the Aid flow (current US$) of 1992 in Sub-Saharan Africa (developing only) to that in Malawi?
Your response must be concise. 2.07. What is the ratio of the Aid flow (current US$) of 1994 in Sub-Saharan Africa (developing only) to that in Malawi?
Provide a short and direct response. 4.74. What is the ratio of the Aid flow (current US$) in 1997 in Sub-Saharan Africa (developing only) to that in Malawi?
Offer a very short reply. 3.67. What is the ratio of the Aid flow (current US$) in 1998 in Sub-Saharan Africa (developing only) to that in Malawi?
Ensure brevity in your answer.  4.82. What is the ratio of the Aid flow (current US$) of 1992 in Upper middle income to that in World?
Offer a terse response. 0.38. What is the ratio of the Aid flow (current US$) in 1994 in Upper middle income to that in World?
Provide a succinct answer. 0.5. What is the ratio of the Aid flow (current US$) of 1997 in Upper middle income to that in World?
Provide a short and direct response. 0.47. What is the ratio of the Aid flow (current US$) of 1998 in Upper middle income to that in World?
Your answer should be compact. 0.46. What is the ratio of the Aid flow (current US$) of 1992 in Upper middle income to that in Malawi?
Your answer should be very brief. 0.93. What is the ratio of the Aid flow (current US$) of 1994 in Upper middle income to that in Malawi?
Your answer should be compact. 2.35. What is the ratio of the Aid flow (current US$) of 1997 in Upper middle income to that in Malawi?
Your answer should be very brief. 2.43. What is the ratio of the Aid flow (current US$) in 1998 in Upper middle income to that in Malawi?
Make the answer very short. 2.68. What is the ratio of the Aid flow (current US$) in 1992 in World to that in Malawi?
Offer a terse response. 2.47. What is the ratio of the Aid flow (current US$) in 1994 in World to that in Malawi?
Provide a short and direct response. 4.74. What is the ratio of the Aid flow (current US$) in 1997 in World to that in Malawi?
Make the answer very short. 5.13. What is the ratio of the Aid flow (current US$) in 1998 in World to that in Malawi?
Offer a terse response. 5.77. What is the difference between the highest and the second highest Aid flow (current US$) of 1997?
Provide a short and direct response. 8.80e+05. What is the difference between the highest and the lowest Aid flow (current US$) of 1992?
Keep it short and to the point. 1.15e+06. What is the difference between the highest and the lowest Aid flow (current US$) of 1994?
Your answer should be very brief. 1.27e+06. What is the difference between the highest and the lowest Aid flow (current US$) of 1997?
Keep it short and to the point. 2.48e+06. What is the difference between the highest and the lowest Aid flow (current US$) in 1998?
Your answer should be compact. 2.10e+06. 